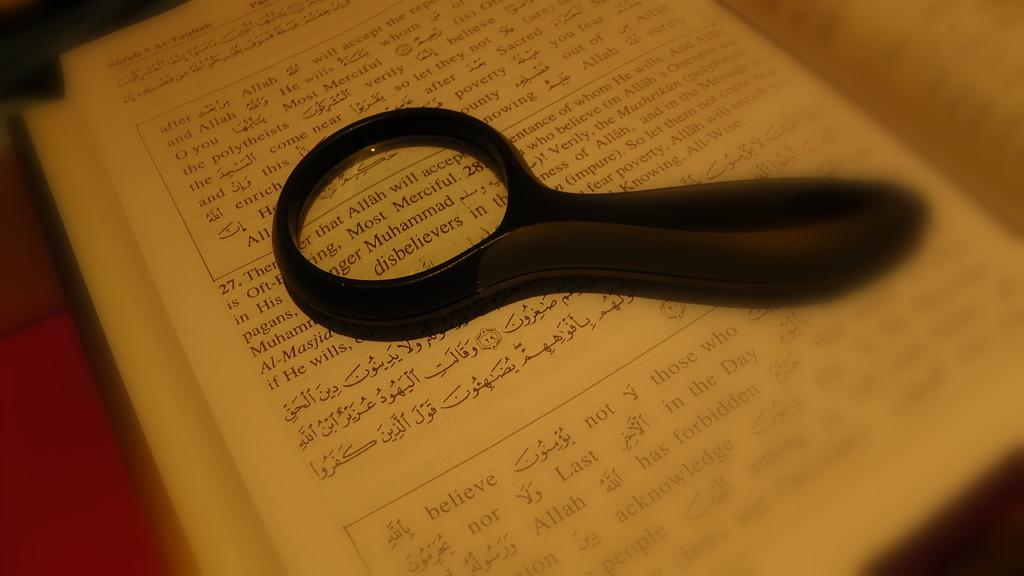Is the passage about muhammad?
Make the answer very short. Yes. What is the first word within the magnify glass?
Your answer should be very brief. That. 